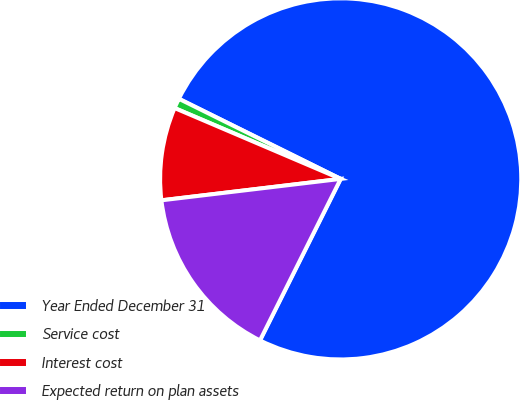Convert chart to OTSL. <chart><loc_0><loc_0><loc_500><loc_500><pie_chart><fcel>Year Ended December 31<fcel>Service cost<fcel>Interest cost<fcel>Expected return on plan assets<nl><fcel>75.06%<fcel>0.9%<fcel>8.31%<fcel>15.73%<nl></chart> 